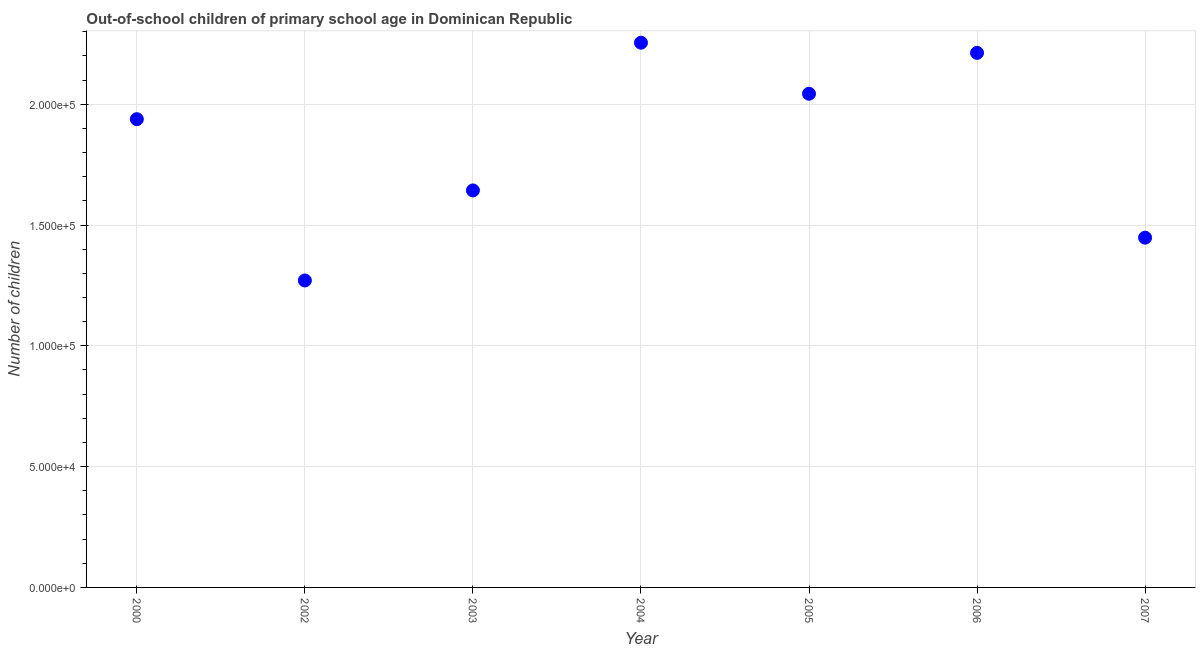What is the number of out-of-school children in 2004?
Offer a very short reply. 2.25e+05. Across all years, what is the maximum number of out-of-school children?
Your response must be concise. 2.25e+05. Across all years, what is the minimum number of out-of-school children?
Make the answer very short. 1.27e+05. In which year was the number of out-of-school children minimum?
Ensure brevity in your answer.  2002. What is the sum of the number of out-of-school children?
Provide a short and direct response. 1.28e+06. What is the difference between the number of out-of-school children in 2003 and 2007?
Your answer should be compact. 1.96e+04. What is the average number of out-of-school children per year?
Ensure brevity in your answer.  1.83e+05. What is the median number of out-of-school children?
Give a very brief answer. 1.94e+05. In how many years, is the number of out-of-school children greater than 130000 ?
Give a very brief answer. 6. What is the ratio of the number of out-of-school children in 2002 to that in 2006?
Keep it short and to the point. 0.57. Is the number of out-of-school children in 2002 less than that in 2007?
Ensure brevity in your answer.  Yes. Is the difference between the number of out-of-school children in 2002 and 2003 greater than the difference between any two years?
Your answer should be very brief. No. What is the difference between the highest and the second highest number of out-of-school children?
Offer a terse response. 4200. Is the sum of the number of out-of-school children in 2004 and 2007 greater than the maximum number of out-of-school children across all years?
Make the answer very short. Yes. What is the difference between the highest and the lowest number of out-of-school children?
Offer a terse response. 9.84e+04. In how many years, is the number of out-of-school children greater than the average number of out-of-school children taken over all years?
Your answer should be compact. 4. Does the number of out-of-school children monotonically increase over the years?
Offer a terse response. No. How many dotlines are there?
Offer a very short reply. 1. Are the values on the major ticks of Y-axis written in scientific E-notation?
Offer a terse response. Yes. Does the graph contain any zero values?
Provide a succinct answer. No. What is the title of the graph?
Offer a very short reply. Out-of-school children of primary school age in Dominican Republic. What is the label or title of the X-axis?
Your answer should be very brief. Year. What is the label or title of the Y-axis?
Your response must be concise. Number of children. What is the Number of children in 2000?
Offer a very short reply. 1.94e+05. What is the Number of children in 2002?
Your answer should be very brief. 1.27e+05. What is the Number of children in 2003?
Make the answer very short. 1.64e+05. What is the Number of children in 2004?
Your response must be concise. 2.25e+05. What is the Number of children in 2005?
Make the answer very short. 2.04e+05. What is the Number of children in 2006?
Ensure brevity in your answer.  2.21e+05. What is the Number of children in 2007?
Your answer should be compact. 1.45e+05. What is the difference between the Number of children in 2000 and 2002?
Your answer should be very brief. 6.68e+04. What is the difference between the Number of children in 2000 and 2003?
Ensure brevity in your answer.  2.95e+04. What is the difference between the Number of children in 2000 and 2004?
Keep it short and to the point. -3.17e+04. What is the difference between the Number of children in 2000 and 2005?
Provide a succinct answer. -1.05e+04. What is the difference between the Number of children in 2000 and 2006?
Keep it short and to the point. -2.75e+04. What is the difference between the Number of children in 2000 and 2007?
Offer a terse response. 4.90e+04. What is the difference between the Number of children in 2002 and 2003?
Make the answer very short. -3.73e+04. What is the difference between the Number of children in 2002 and 2004?
Offer a very short reply. -9.84e+04. What is the difference between the Number of children in 2002 and 2005?
Your response must be concise. -7.73e+04. What is the difference between the Number of children in 2002 and 2006?
Provide a short and direct response. -9.42e+04. What is the difference between the Number of children in 2002 and 2007?
Give a very brief answer. -1.77e+04. What is the difference between the Number of children in 2003 and 2004?
Ensure brevity in your answer.  -6.11e+04. What is the difference between the Number of children in 2003 and 2005?
Offer a terse response. -4.00e+04. What is the difference between the Number of children in 2003 and 2006?
Your answer should be very brief. -5.69e+04. What is the difference between the Number of children in 2003 and 2007?
Provide a succinct answer. 1.96e+04. What is the difference between the Number of children in 2004 and 2005?
Offer a terse response. 2.11e+04. What is the difference between the Number of children in 2004 and 2006?
Provide a succinct answer. 4200. What is the difference between the Number of children in 2004 and 2007?
Offer a very short reply. 8.07e+04. What is the difference between the Number of children in 2005 and 2006?
Ensure brevity in your answer.  -1.69e+04. What is the difference between the Number of children in 2005 and 2007?
Provide a short and direct response. 5.96e+04. What is the difference between the Number of children in 2006 and 2007?
Offer a very short reply. 7.65e+04. What is the ratio of the Number of children in 2000 to that in 2002?
Your response must be concise. 1.52. What is the ratio of the Number of children in 2000 to that in 2003?
Your answer should be very brief. 1.18. What is the ratio of the Number of children in 2000 to that in 2004?
Your response must be concise. 0.86. What is the ratio of the Number of children in 2000 to that in 2005?
Ensure brevity in your answer.  0.95. What is the ratio of the Number of children in 2000 to that in 2006?
Your answer should be very brief. 0.88. What is the ratio of the Number of children in 2000 to that in 2007?
Give a very brief answer. 1.34. What is the ratio of the Number of children in 2002 to that in 2003?
Offer a very short reply. 0.77. What is the ratio of the Number of children in 2002 to that in 2004?
Provide a succinct answer. 0.56. What is the ratio of the Number of children in 2002 to that in 2005?
Provide a succinct answer. 0.62. What is the ratio of the Number of children in 2002 to that in 2006?
Provide a short and direct response. 0.57. What is the ratio of the Number of children in 2002 to that in 2007?
Provide a short and direct response. 0.88. What is the ratio of the Number of children in 2003 to that in 2004?
Keep it short and to the point. 0.73. What is the ratio of the Number of children in 2003 to that in 2005?
Your response must be concise. 0.8. What is the ratio of the Number of children in 2003 to that in 2006?
Keep it short and to the point. 0.74. What is the ratio of the Number of children in 2003 to that in 2007?
Provide a succinct answer. 1.14. What is the ratio of the Number of children in 2004 to that in 2005?
Your answer should be very brief. 1.1. What is the ratio of the Number of children in 2004 to that in 2007?
Your response must be concise. 1.56. What is the ratio of the Number of children in 2005 to that in 2006?
Give a very brief answer. 0.92. What is the ratio of the Number of children in 2005 to that in 2007?
Offer a very short reply. 1.41. What is the ratio of the Number of children in 2006 to that in 2007?
Offer a very short reply. 1.53. 